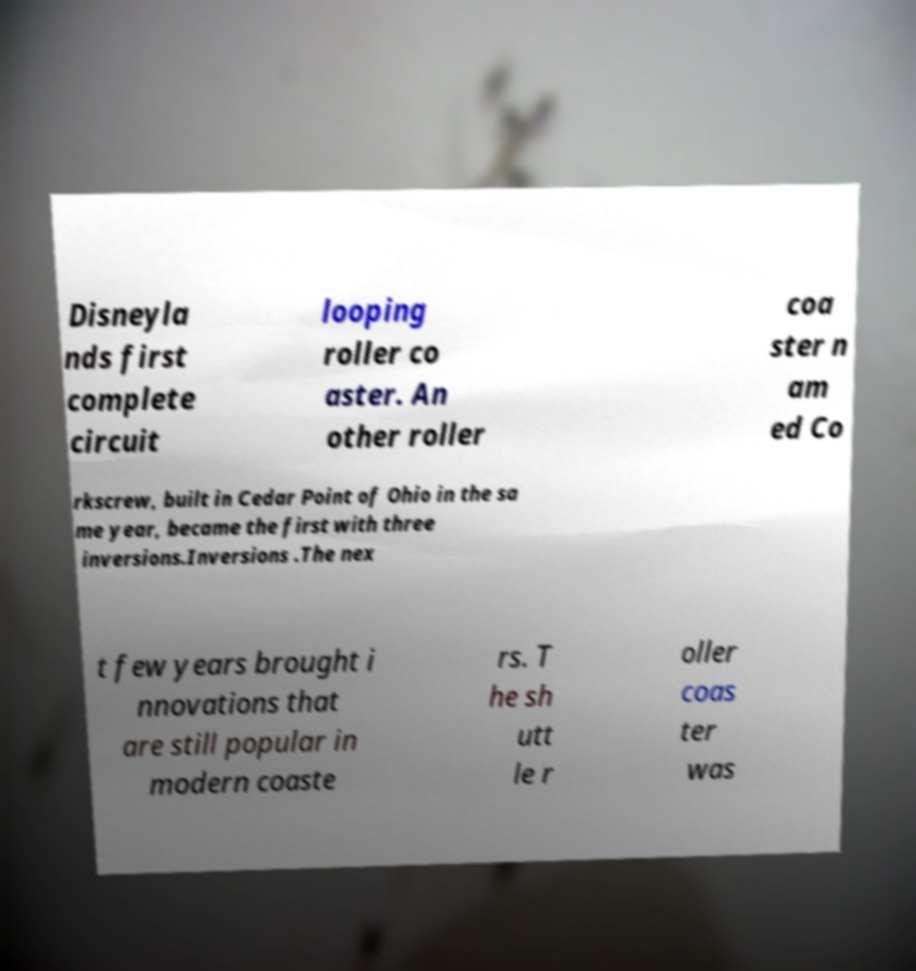Could you assist in decoding the text presented in this image and type it out clearly? Disneyla nds first complete circuit looping roller co aster. An other roller coa ster n am ed Co rkscrew, built in Cedar Point of Ohio in the sa me year, became the first with three inversions.Inversions .The nex t few years brought i nnovations that are still popular in modern coaste rs. T he sh utt le r oller coas ter was 